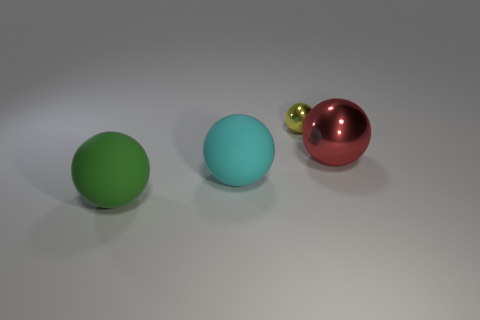Is the material of the cyan thing the same as the big green sphere?
Ensure brevity in your answer.  Yes. What number of cyan spheres are behind the big cyan ball?
Offer a very short reply. 0. There is a large object that is in front of the large shiny sphere and to the right of the big green sphere; what is its material?
Your answer should be very brief. Rubber. What number of balls are either tiny metallic things or big cyan things?
Offer a terse response. 2. There is a big green object that is the same shape as the yellow metal object; what is its material?
Make the answer very short. Rubber. The red ball that is the same material as the tiny object is what size?
Provide a succinct answer. Large. Is the shape of the large object right of the small thing the same as the object behind the red metal object?
Provide a short and direct response. Yes. What is the color of the tiny ball that is the same material as the red thing?
Offer a terse response. Yellow. There is a object that is right of the small ball; is it the same size as the thing on the left side of the cyan object?
Keep it short and to the point. Yes. There is a big thing that is both left of the big red thing and on the right side of the green rubber ball; what is its shape?
Your answer should be very brief. Sphere. 